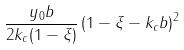Convert formula to latex. <formula><loc_0><loc_0><loc_500><loc_500>\frac { y _ { 0 } b } { 2 k _ { c } ( 1 - \xi ) } \left ( 1 - \xi - k _ { c } b \right ) ^ { 2 }</formula> 